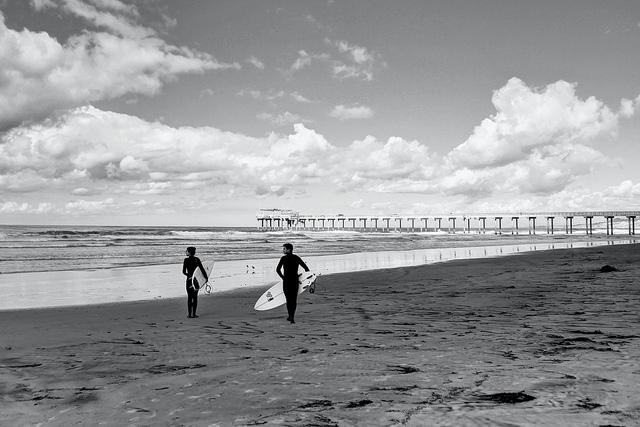Are the waves large?
Answer briefly. No. Is it going to storm?
Write a very short answer. No. Are they on the beach?
Answer briefly. Yes. What are the people holding?
Concise answer only. Surfboards. How many people are in this scene?
Concise answer only. 2. What are the people playing?
Quick response, please. Surfing. 